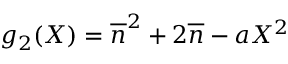<formula> <loc_0><loc_0><loc_500><loc_500>g _ { 2 } ( X ) = \overline { n } ^ { 2 } + 2 \overline { n } - a X ^ { 2 }</formula> 